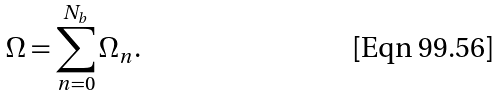<formula> <loc_0><loc_0><loc_500><loc_500>\Omega = \sum _ { n = 0 } ^ { N _ { b } } \Omega _ { n } .</formula> 